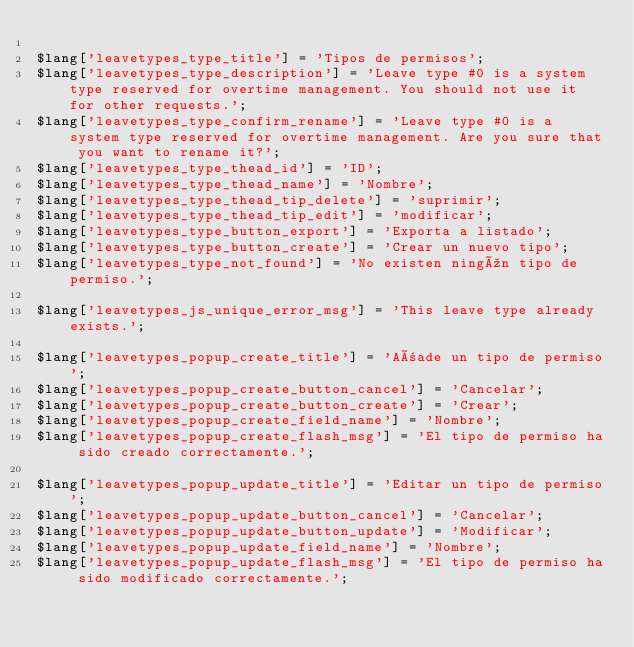Convert code to text. <code><loc_0><loc_0><loc_500><loc_500><_PHP_>
$lang['leavetypes_type_title'] = 'Tipos de permisos';
$lang['leavetypes_type_description'] = 'Leave type #0 is a system type reserved for overtime management. You should not use it for other requests.';
$lang['leavetypes_type_confirm_rename'] = 'Leave type #0 is a system type reserved for overtime management. Are you sure that you want to rename it?';
$lang['leavetypes_type_thead_id'] = 'ID';
$lang['leavetypes_type_thead_name'] = 'Nombre';
$lang['leavetypes_type_thead_tip_delete'] = 'suprimir';
$lang['leavetypes_type_thead_tip_edit'] = 'modificar';
$lang['leavetypes_type_button_export'] = 'Exporta a listado';
$lang['leavetypes_type_button_create'] = 'Crear un nuevo tipo';
$lang['leavetypes_type_not_found'] = 'No existen ningún tipo de permiso.';

$lang['leavetypes_js_unique_error_msg'] = 'This leave type already exists.';

$lang['leavetypes_popup_create_title'] = 'Añade un tipo de permiso';
$lang['leavetypes_popup_create_button_cancel'] = 'Cancelar';
$lang['leavetypes_popup_create_button_create'] = 'Crear';
$lang['leavetypes_popup_create_field_name'] = 'Nombre';
$lang['leavetypes_popup_create_flash_msg'] = 'El tipo de permiso ha sido creado correctamente.';

$lang['leavetypes_popup_update_title'] = 'Editar un tipo de permiso';
$lang['leavetypes_popup_update_button_cancel'] = 'Cancelar';
$lang['leavetypes_popup_update_button_update'] = 'Modificar';
$lang['leavetypes_popup_update_field_name'] = 'Nombre';
$lang['leavetypes_popup_update_flash_msg'] = 'El tipo de permiso ha sido modificado correctamente.';
</code> 